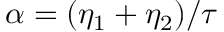<formula> <loc_0><loc_0><loc_500><loc_500>\alpha = ( \eta _ { 1 } + \eta _ { 2 } ) / \tau</formula> 